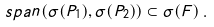<formula> <loc_0><loc_0><loc_500><loc_500>s p a n ( \sigma ( P _ { 1 } ) , \sigma ( P _ { 2 } ) ) \subset \sigma ( F ) \, .</formula> 